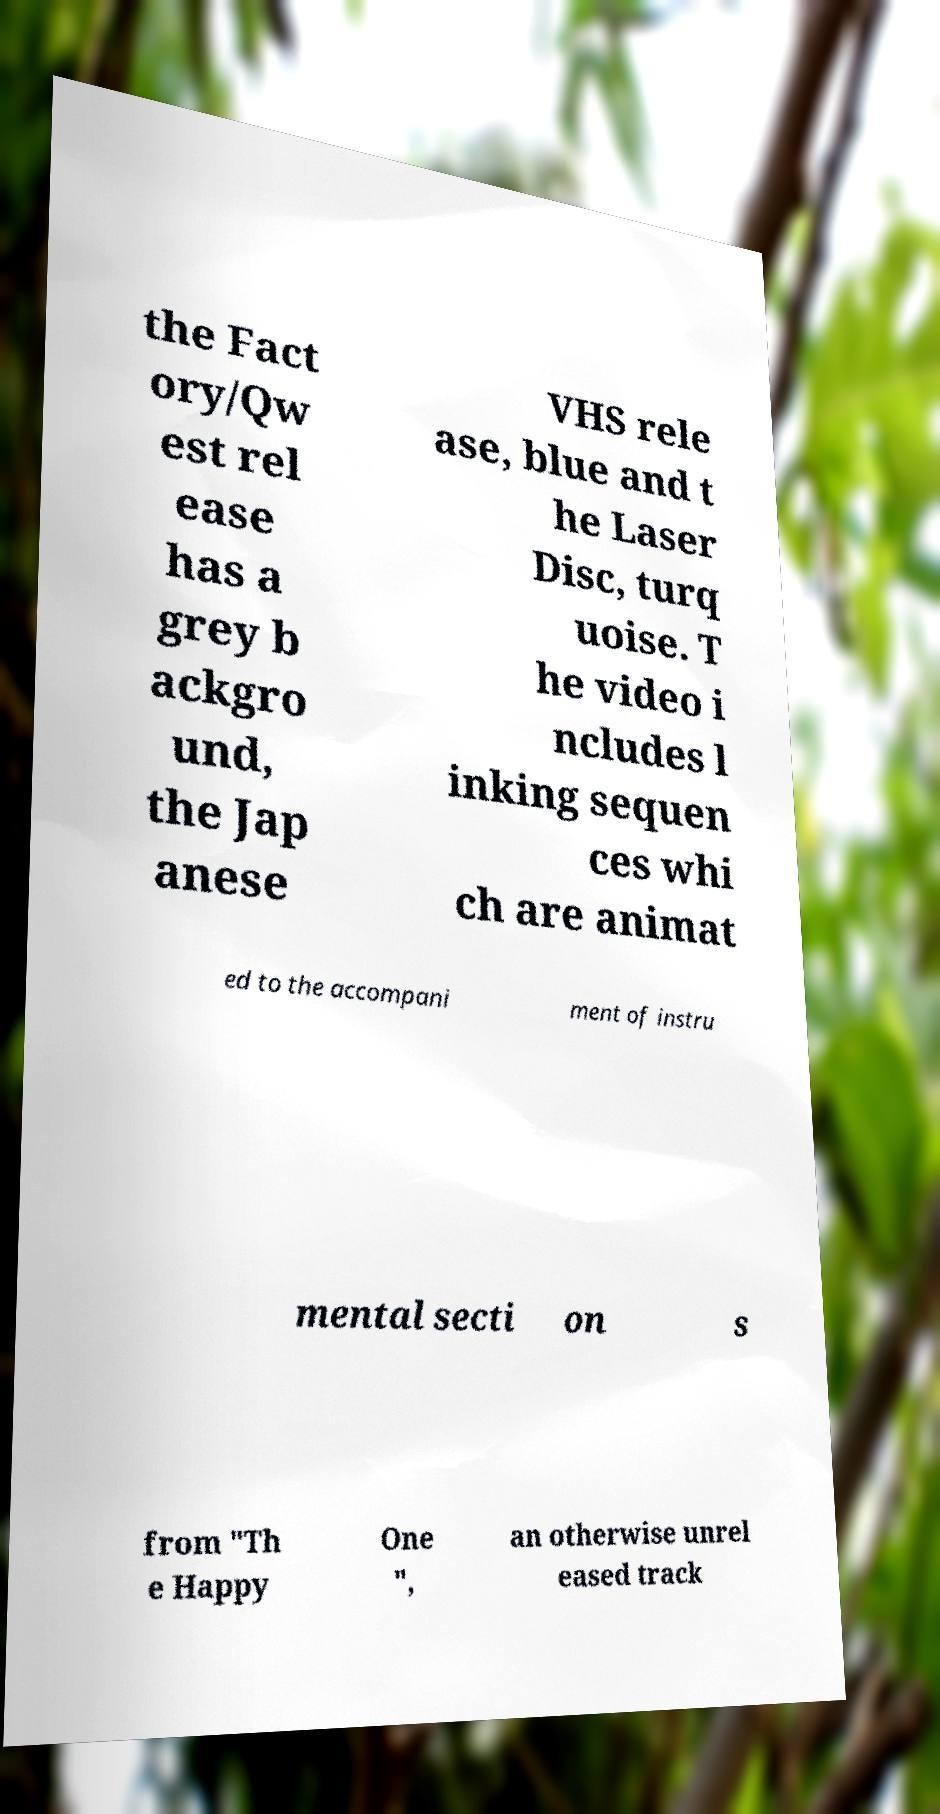What messages or text are displayed in this image? I need them in a readable, typed format. the Fact ory/Qw est rel ease has a grey b ackgro und, the Jap anese VHS rele ase, blue and t he Laser Disc, turq uoise. T he video i ncludes l inking sequen ces whi ch are animat ed to the accompani ment of instru mental secti on s from "Th e Happy One ", an otherwise unrel eased track 